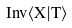<formula> <loc_0><loc_0><loc_500><loc_500>I n v \langle X | T \rangle</formula> 